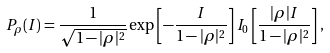<formula> <loc_0><loc_0><loc_500><loc_500>P _ { \rho } ( I ) = \frac { 1 } { \sqrt { 1 - | \rho | ^ { 2 } } } \exp \left [ - \frac { I } { 1 - | \rho | ^ { 2 } } \right ] I _ { 0 } \left [ \frac { | \rho | I } { 1 - | \rho | ^ { 2 } } \right ] ,</formula> 